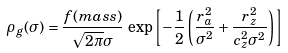<formula> <loc_0><loc_0><loc_500><loc_500>\rho _ { g } ( \sigma ) = \frac { f ( m a s s ) } { \sqrt { 2 \pi } \sigma } \, \exp \left [ - \frac { 1 } { 2 } \left ( \frac { r _ { a } ^ { 2 } } { \sigma ^ { 2 } } + \frac { r _ { z } ^ { 2 } } { c _ { z } ^ { 2 } \sigma ^ { 2 } } \right ) \right ]</formula> 